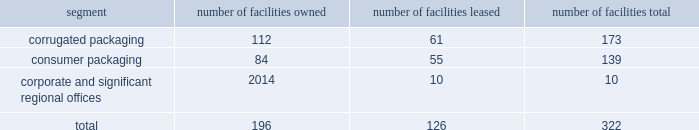Consume significant amounts of energy , and we may in the future incur additional or increased capital , operating and other expenditures from changes due to new or increased climate-related and other environmental regulations .
We could also incur substantial liabilities , including fines or sanctions , enforcement actions , natural resource damages claims , cleanup and closure costs , and third-party claims for property damage and personal injury under environmental and common laws .
The foreign corrupt practices act of 1977 and local anti-bribery laws , including those in brazil , china , mexico , india and the united kingdom ( where we maintain operations directly or through a joint venture ) , prohibit companies and their intermediaries from making improper payments to government officials for the purpose of influencing official decisions .
Our internal control policies and procedures , or those of our vendors , may not adequately protect us from reckless or criminal acts committed or alleged to have been committed by our employees , agents or vendors .
Any such violations could lead to civil or criminal monetary and non-monetary penalties and/or could damage our reputation .
We are subject to a number of labor and employment laws and regulations that could significantly increase our operating costs and reduce our operational flexibility .
Additionally , changing privacy laws in the united states ( including the california consumer privacy act , which will become effective in january 2020 ) , europe ( where the general data protection regulation became effective in 2018 ) and elsewhere have created new individual privacy rights , imposed increased obligations on companies handling personal data and increased potential exposure to fines and penalties .
Item 1b .
Unresolved staff comments there are no unresolved sec staff comments .
Item 2 .
Properties we operate locations in north america , including the majority of u.s .
States , south america , europe , asia and australia .
We lease our principal offices in atlanta , ga .
We believe that our existing production capacity is adequate to serve existing demand for our products and consider our plants and equipment to be in good condition .
Our corporate and operating facilities as of september 30 , 2019 are summarized below: .
The tables that follow show our annual production capacity by mill at september 30 , 2019 in thousands of tons , except for the north charleston , sc mill which reflects our capacity after the previously announced machine closure expected to occur in fiscal 2020 .
Our mill system production levels and operating rates may vary from year to year due to changes in market and other factors , including the impact of hurricanes and other weather-related events .
Our simple average mill system operating rates for the last three years averaged 94% ( 94 % ) .
We own all of our mills. .
What was the ratio of the corrugated packaging number of facilities owned to those leased? 
Computations: (112 / 61)
Answer: 1.83607. 